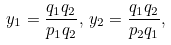Convert formula to latex. <formula><loc_0><loc_0><loc_500><loc_500>y _ { 1 } = \frac { q _ { 1 } q _ { 2 } } { p _ { 1 } q _ { 2 } } , \, y _ { 2 } = \frac { q _ { 1 } q _ { 2 } } { p _ { 2 } q _ { 1 } } ,</formula> 